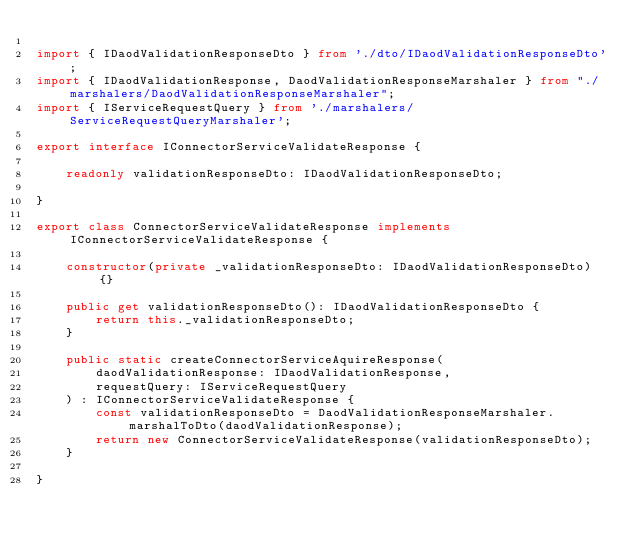<code> <loc_0><loc_0><loc_500><loc_500><_TypeScript_>
import { IDaodValidationResponseDto } from './dto/IDaodValidationResponseDto';
import { IDaodValidationResponse, DaodValidationResponseMarshaler } from "./marshalers/DaodValidationResponseMarshaler";
import { IServiceRequestQuery } from './marshalers/ServiceRequestQueryMarshaler';

export interface IConnectorServiceValidateResponse {

    readonly validationResponseDto: IDaodValidationResponseDto;
    
}

export class ConnectorServiceValidateResponse implements IConnectorServiceValidateResponse {

    constructor(private _validationResponseDto: IDaodValidationResponseDto) {}

    public get validationResponseDto(): IDaodValidationResponseDto {
        return this._validationResponseDto;
    }

    public static createConnectorServiceAquireResponse(
        daodValidationResponse: IDaodValidationResponse, 
        requestQuery: IServiceRequestQuery
    ) : IConnectorServiceValidateResponse {
        const validationResponseDto = DaodValidationResponseMarshaler.marshalToDto(daodValidationResponse);
        return new ConnectorServiceValidateResponse(validationResponseDto);
    }

}</code> 